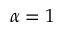Convert formula to latex. <formula><loc_0><loc_0><loc_500><loc_500>\alpha = 1</formula> 